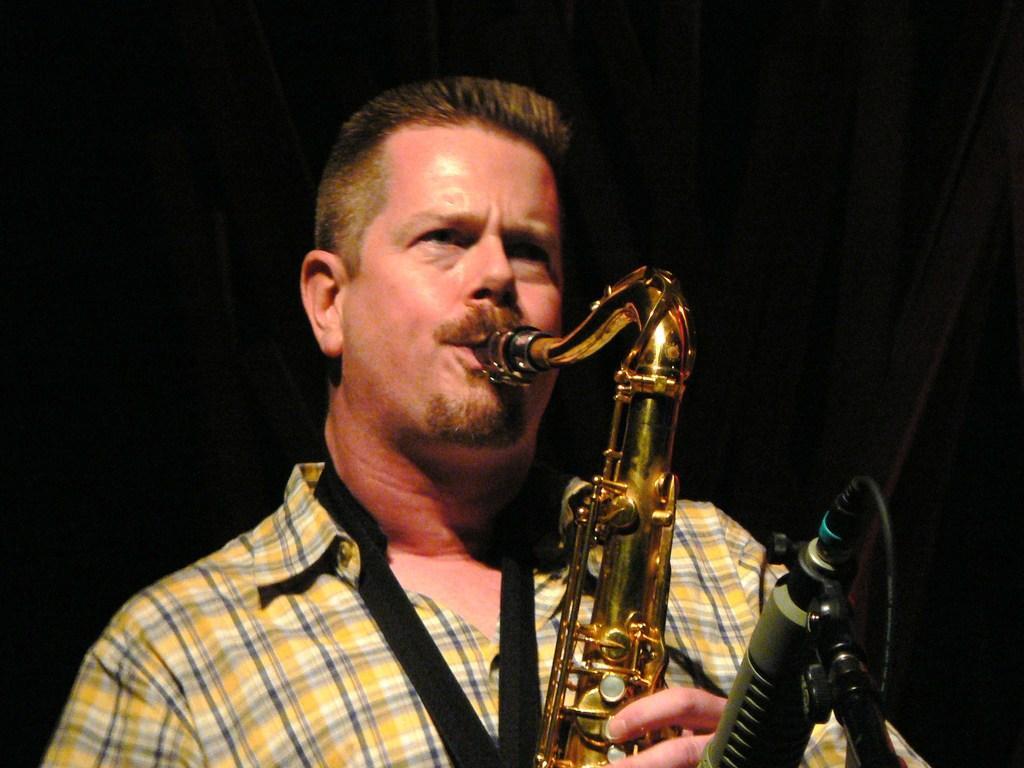Please provide a concise description of this image. In this image we can see a person playing a musical instrument and the background is dark. 